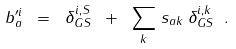<formula> <loc_0><loc_0><loc_500><loc_500>b ^ { \prime i } _ { a } \ = \ \delta ^ { i , S } _ { G S } \ + \ \sum _ { k } \, s _ { a k } \, \delta ^ { i , k } _ { G S } \ .</formula> 